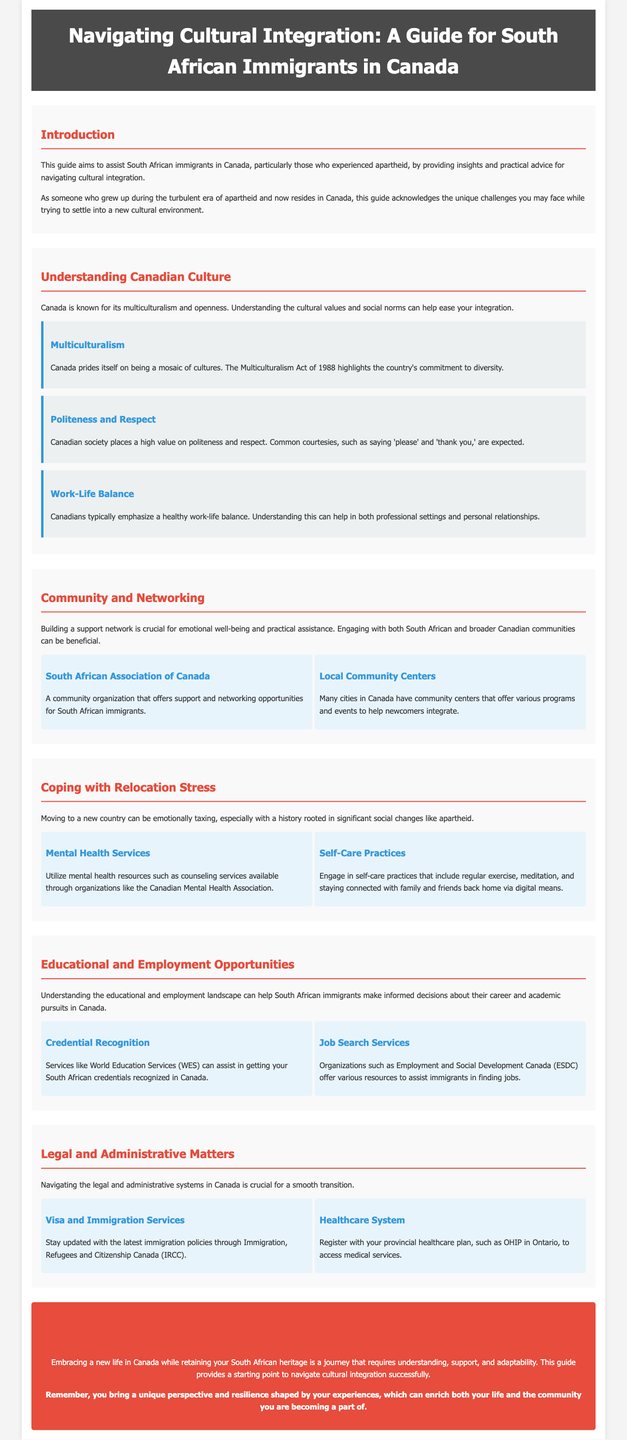What is the main purpose of this guide? The guide aims to assist South African immigrants in Canada by providing insights and practical advice for navigating cultural integration.
Answer: Assist South African immigrants What year was the Multiculturalism Act established? The document mentions the Multiculturalism Act of 1988, highlighting Canada’s commitment to diversity.
Answer: 1988 What organization offers support for South African immigrants? The guide refers to the South African Association of Canada as a community organization that offers support.
Answer: South African Association of Canada Which service helps recognize South African educational credentials in Canada? The document mentions World Education Services (WES) as a service that assists in getting South African credentials recognized.
Answer: World Education Services (WES) What is one of the self-care practices suggested? The guide suggests regular exercise as one of the self-care practices to engage in.
Answer: Regular exercise How can newcomers access healthcare services in Canada? Newcomers are advised to register with their provincial healthcare plan to access medical services.
Answer: Register with provincial healthcare plan What aspect of Canadian society is emphasized in the document? The emphasis is on politeness and respect as high values in Canadian society.
Answer: Politeness and respect What are newcomers encouraged to do to cope with relocation stress? The guide encourages utilizing mental health resources such as counseling services to cope with stress.
Answer: Utilize mental health resources What does the conclusion suggest for South African immigrants in Canada? The conclusion suggests that embracing a new life while retaining South African heritage is crucial for successful integration.
Answer: Embrace new life while retaining heritage 